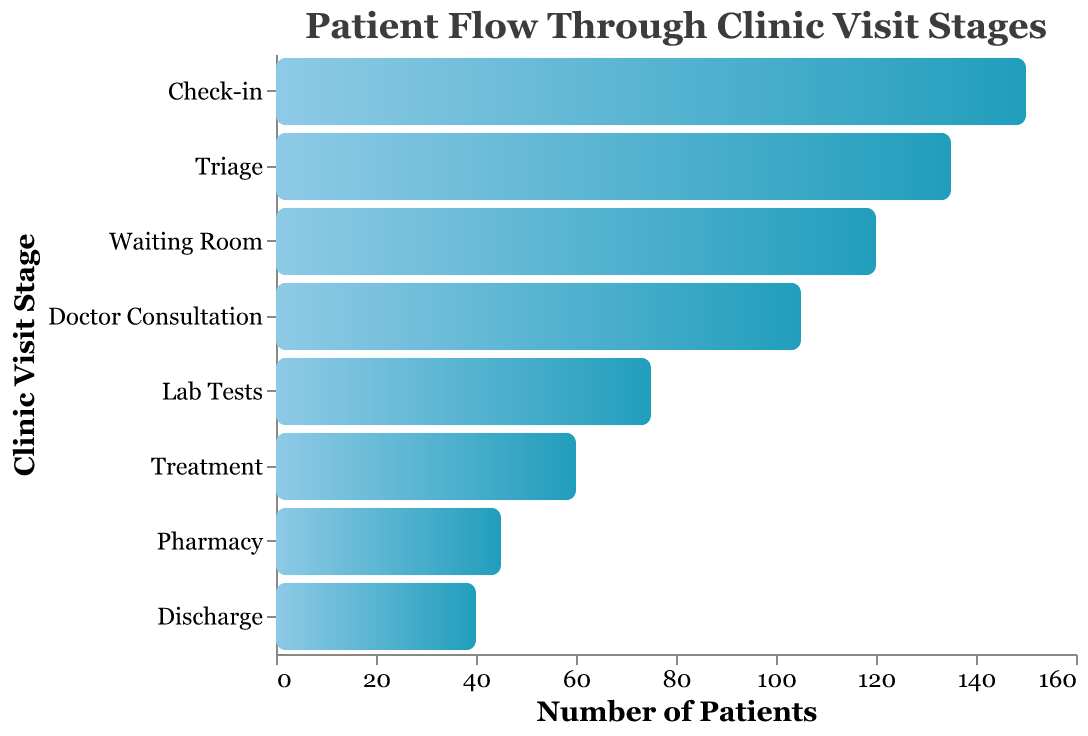What's the title of the figure? The title of the figure is visible at the top, indicating the main subject of the chart. It reads "Patient Flow Through Clinic Visit Stages."
Answer: Patient Flow Through Clinic Visit Stages How many stages are represented in the figure? Count the number of distinct stages listed along the vertical axis. There are eight stages indicated.
Answer: Eight Which stage has the highest number of patients? The highest bar on the x-axis corresponds to the "Check-in" stage, indicating the highest patient count of 150.
Answer: Check-in How many patients are present in the "Doctor Consultation" stage? Locate the bar corresponding to the "Doctor Consultation" stage and refer to its length on the x-axis, which shows 105 patients.
Answer: 105 What is the difference in patient numbers between the "Triage" and "Waiting Room" stages? Subtract the number of patients in the "Waiting Room" stage (120) from the "Triage" stage (135). 135 - 120 = 15 patients.
Answer: 15 What percentage of patients move from "Check-in" to "Discharge"? Calculate the ratio of patients at "Discharge" (40) to patients at "Check-in" (150) and multiply by 100 to get the percentage: (40/150) * 100 ≈ 26.7%.
Answer: 26.7% Which stage shows a greater drop in the number of patients, "Lab Tests" to "Treatment" or "Pharmacy" to "Discharge"? Calculate the patient drop for each stage: "Lab Tests" to "Treatment" (75 - 60 = 15) and "Pharmacy" to "Discharge" (45 - 40 = 5). The "Lab Tests" to "Treatment" stage has a greater drop of 15 patients.
Answer: Lab Tests to Treatment Are there more patients in the "Pharmacy" stage than in the "Treatment" stage? Compare the patient numbers in both stages: Treatment (60) and Pharmacy (45). Treatment has more patients than Pharmacy.
Answer: No How many total patients are there if you sum up all of the stages? Sum the patient numbers in all the stages: 150 + 135 + 120 + 105 + 75 + 60 + 45 + 40 = 730 patients.
Answer: 730 Is the number of patients decreasing at every stage? Examine each stage sequentially: Check-in (150), Triage (135), Waiting Room (120), Doctor Consultation (105), Lab Tests (75), Treatment (60), Pharmacy (45), Discharge (40). The patient count decreases step-by-step.
Answer: Yes 